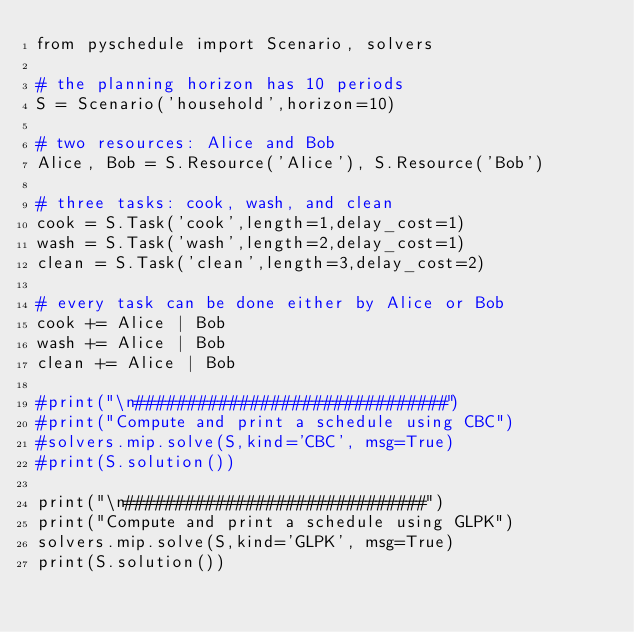<code> <loc_0><loc_0><loc_500><loc_500><_Python_>from pyschedule import Scenario, solvers

# the planning horizon has 10 periods
S = Scenario('household',horizon=10)

# two resources: Alice and Bob
Alice, Bob = S.Resource('Alice'), S.Resource('Bob')

# three tasks: cook, wash, and clean
cook = S.Task('cook',length=1,delay_cost=1)
wash = S.Task('wash',length=2,delay_cost=1)
clean = S.Task('clean',length=3,delay_cost=2)

# every task can be done either by Alice or Bob
cook += Alice | Bob
wash += Alice | Bob
clean += Alice | Bob

#print("\n##############################")
#print("Compute and print a schedule using CBC")
#solvers.mip.solve(S,kind='CBC', msg=True)
#print(S.solution())

print("\n##############################")
print("Compute and print a schedule using GLPK")
solvers.mip.solve(S,kind='GLPK', msg=True)
print(S.solution())
</code> 